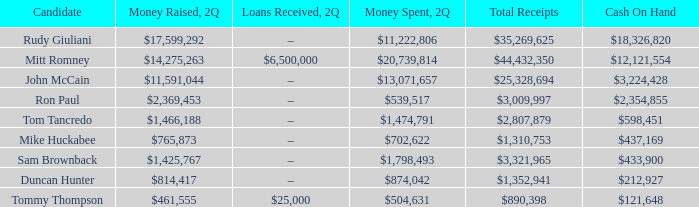Reveal the sum of all incomes for tom tancredo. $2,807,879. 